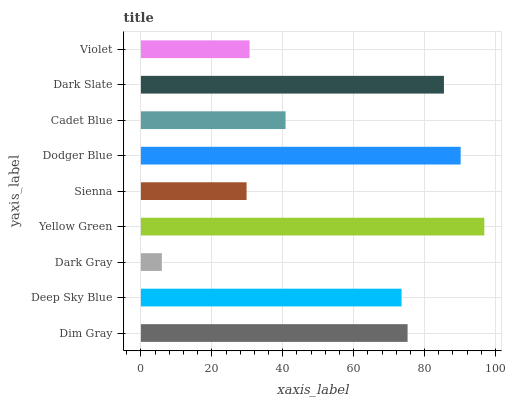Is Dark Gray the minimum?
Answer yes or no. Yes. Is Yellow Green the maximum?
Answer yes or no. Yes. Is Deep Sky Blue the minimum?
Answer yes or no. No. Is Deep Sky Blue the maximum?
Answer yes or no. No. Is Dim Gray greater than Deep Sky Blue?
Answer yes or no. Yes. Is Deep Sky Blue less than Dim Gray?
Answer yes or no. Yes. Is Deep Sky Blue greater than Dim Gray?
Answer yes or no. No. Is Dim Gray less than Deep Sky Blue?
Answer yes or no. No. Is Deep Sky Blue the high median?
Answer yes or no. Yes. Is Deep Sky Blue the low median?
Answer yes or no. Yes. Is Violet the high median?
Answer yes or no. No. Is Dim Gray the low median?
Answer yes or no. No. 